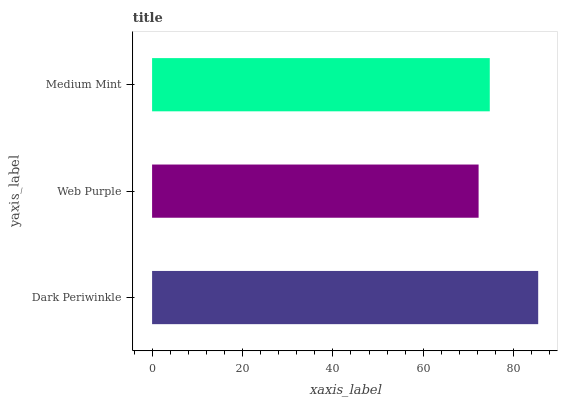Is Web Purple the minimum?
Answer yes or no. Yes. Is Dark Periwinkle the maximum?
Answer yes or no. Yes. Is Medium Mint the minimum?
Answer yes or no. No. Is Medium Mint the maximum?
Answer yes or no. No. Is Medium Mint greater than Web Purple?
Answer yes or no. Yes. Is Web Purple less than Medium Mint?
Answer yes or no. Yes. Is Web Purple greater than Medium Mint?
Answer yes or no. No. Is Medium Mint less than Web Purple?
Answer yes or no. No. Is Medium Mint the high median?
Answer yes or no. Yes. Is Medium Mint the low median?
Answer yes or no. Yes. Is Web Purple the high median?
Answer yes or no. No. Is Dark Periwinkle the low median?
Answer yes or no. No. 